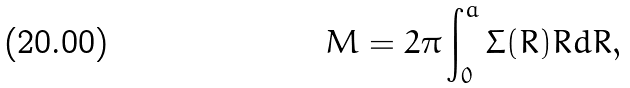Convert formula to latex. <formula><loc_0><loc_0><loc_500><loc_500>M = { 2 \pi } \int _ { 0 } ^ { a } \Sigma ( R ) R d R ,</formula> 